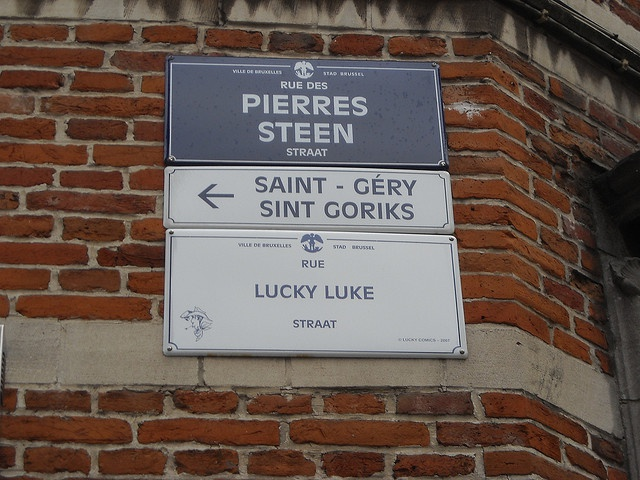Describe the objects in this image and their specific colors. I can see various objects in this image with different colors. 